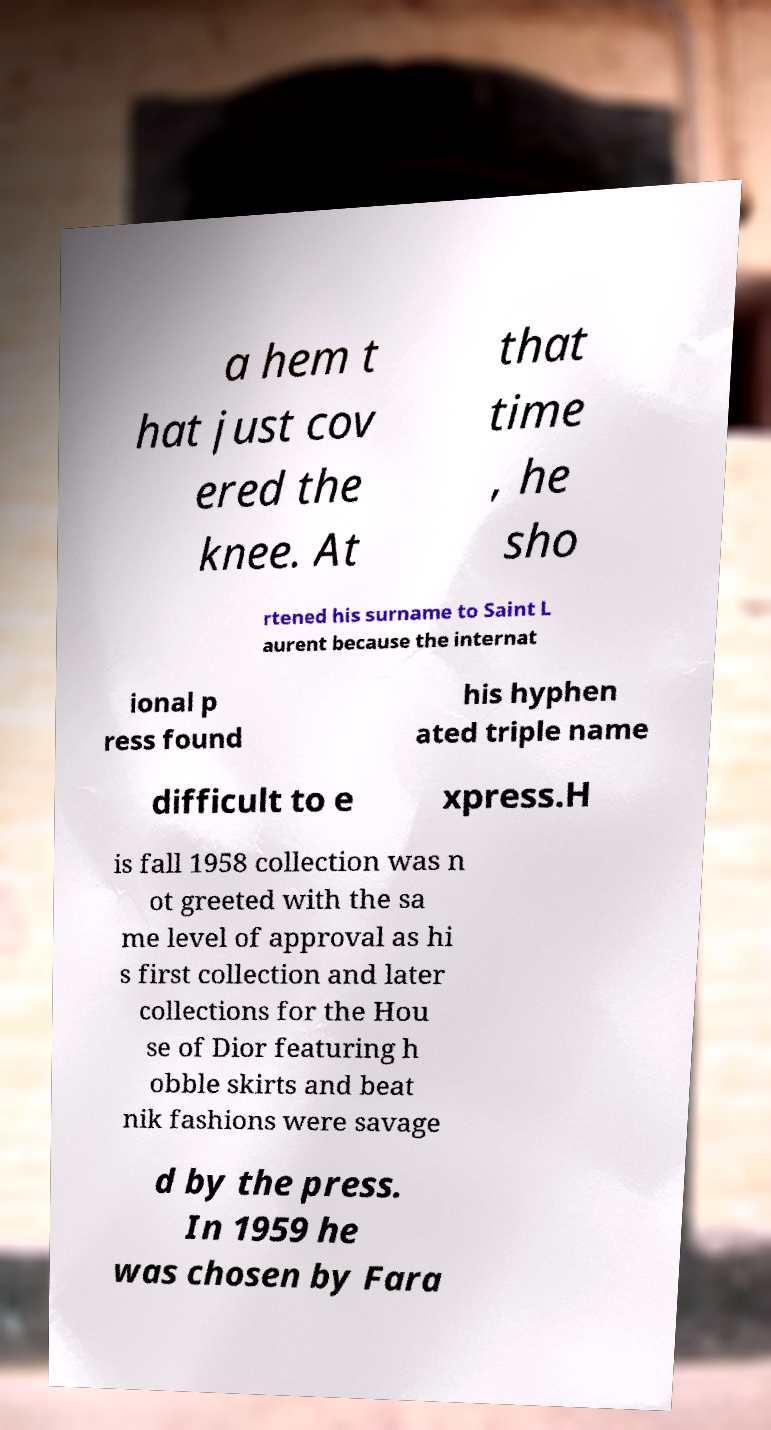Could you assist in decoding the text presented in this image and type it out clearly? a hem t hat just cov ered the knee. At that time , he sho rtened his surname to Saint L aurent because the internat ional p ress found his hyphen ated triple name difficult to e xpress.H is fall 1958 collection was n ot greeted with the sa me level of approval as hi s first collection and later collections for the Hou se of Dior featuring h obble skirts and beat nik fashions were savage d by the press. In 1959 he was chosen by Fara 